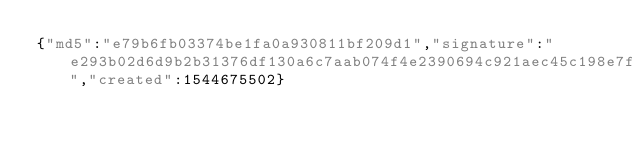Convert code to text. <code><loc_0><loc_0><loc_500><loc_500><_SML_>{"md5":"e79b6fb03374be1fa0a930811bf209d1","signature":"e293b02d6d9b2b31376df130a6c7aab074f4e2390694c921aec45c198e7ff39309ecb8bf80a3556f5f5baecbc1c5829693726cbc7c1c9c0848313b5cac31e405","created":1544675502}</code> 